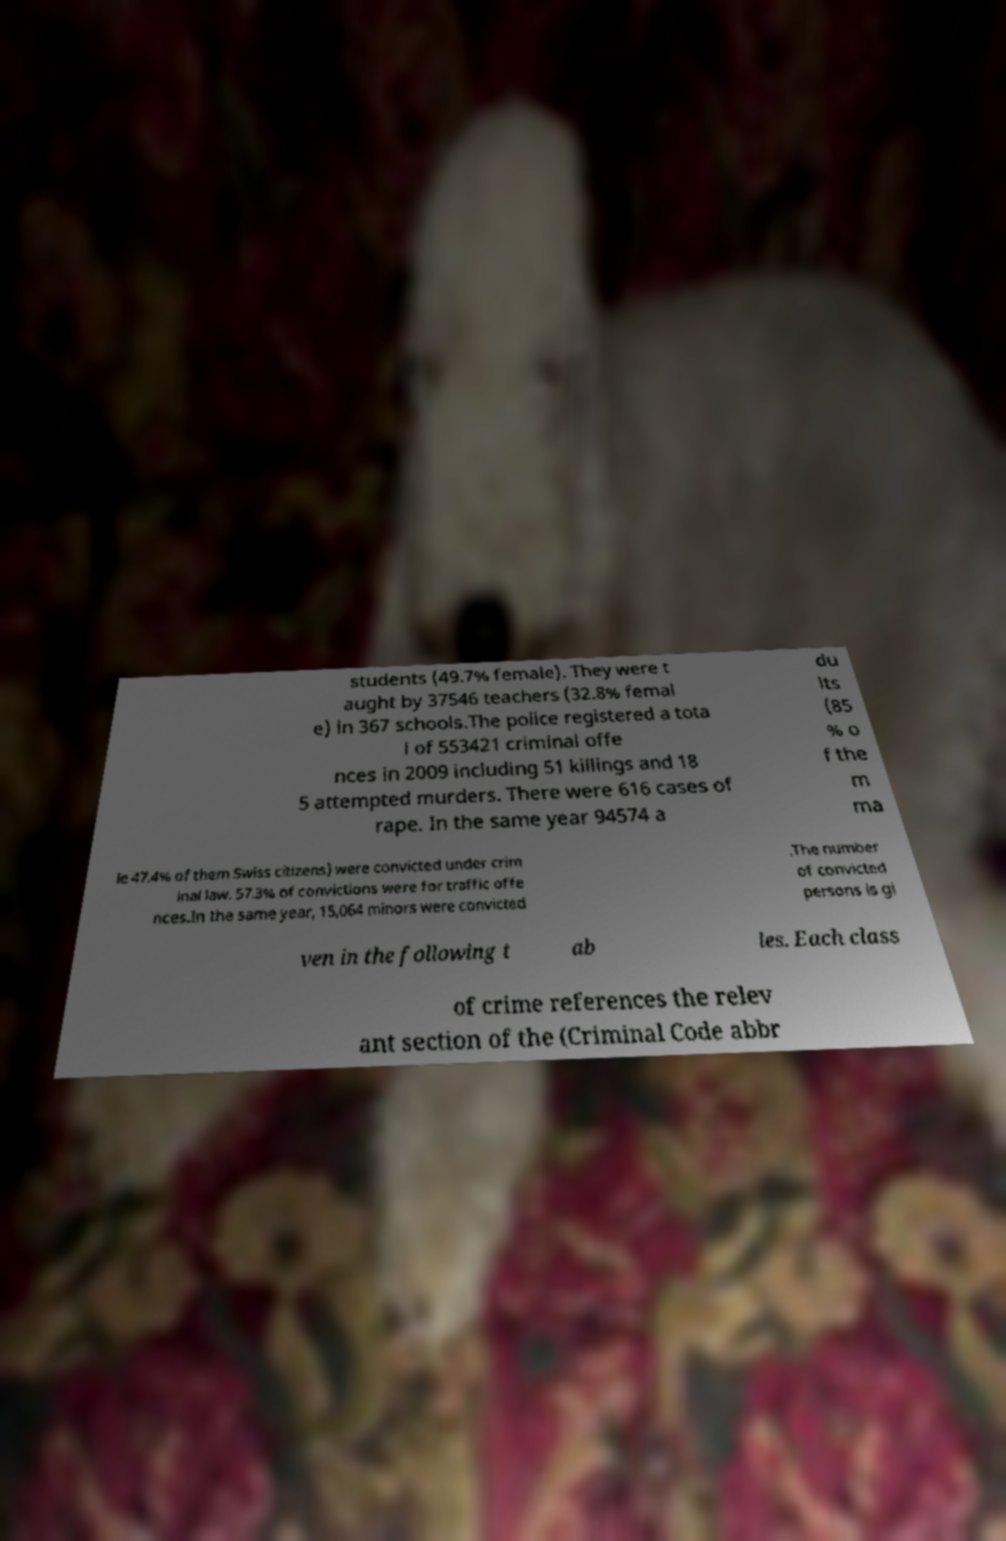Can you accurately transcribe the text from the provided image for me? students (49.7% female). They were t aught by 37546 teachers (32.8% femal e) in 367 schools.The police registered a tota l of 553421 criminal offe nces in 2009 including 51 killings and 18 5 attempted murders. There were 616 cases of rape. In the same year 94574 a du lts (85 % o f the m ma le 47.4% of them Swiss citizens) were convicted under crim inal law. 57.3% of convictions were for traffic offe nces.In the same year, 15,064 minors were convicted .The number of convicted persons is gi ven in the following t ab les. Each class of crime references the relev ant section of the (Criminal Code abbr 